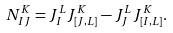Convert formula to latex. <formula><loc_0><loc_0><loc_500><loc_500>N _ { I J } ^ { K } = J _ { I } ^ { L } J _ { [ J , L ] } ^ { K } - J _ { J } ^ { L } J _ { [ I , L ] } ^ { K } .</formula> 